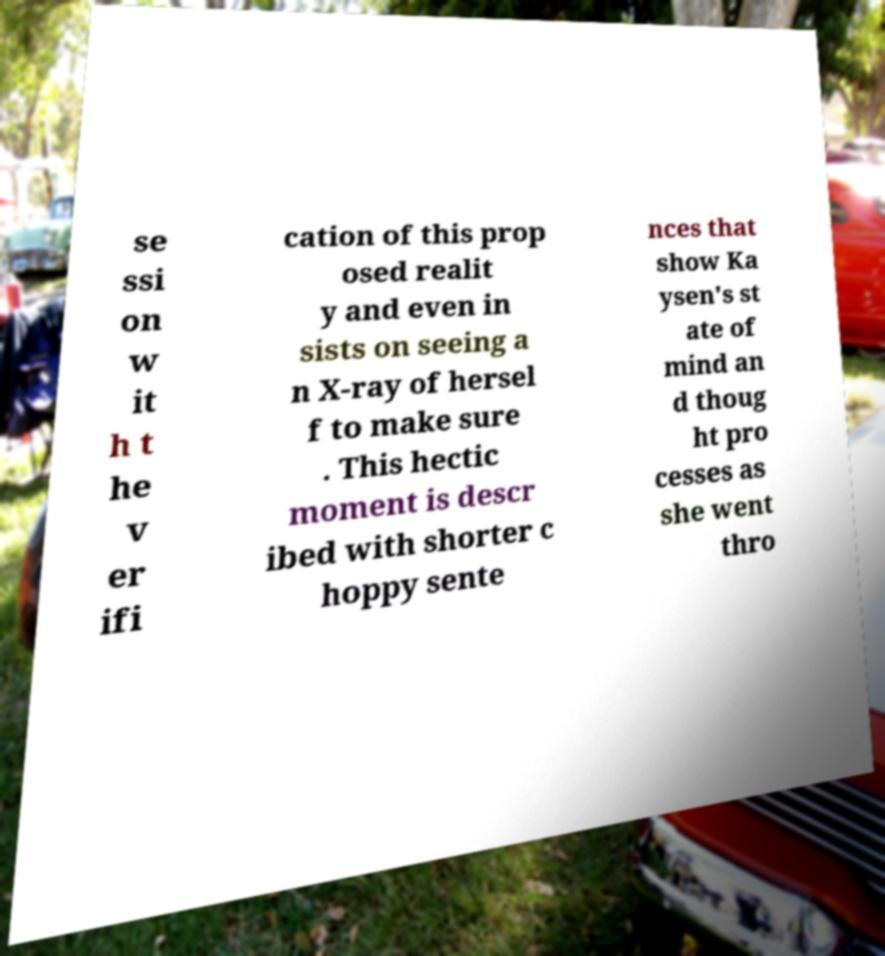Please read and relay the text visible in this image. What does it say? se ssi on w it h t he v er ifi cation of this prop osed realit y and even in sists on seeing a n X-ray of hersel f to make sure . This hectic moment is descr ibed with shorter c hoppy sente nces that show Ka ysen's st ate of mind an d thoug ht pro cesses as she went thro 